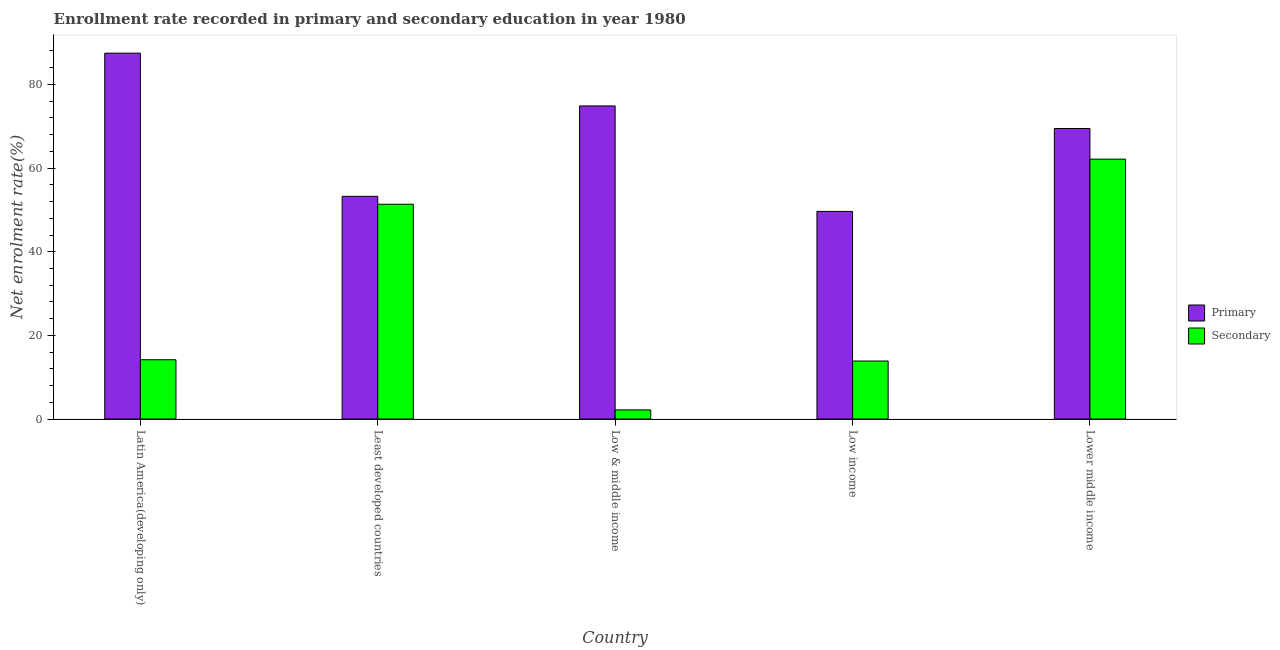How many groups of bars are there?
Provide a succinct answer. 5. How many bars are there on the 2nd tick from the right?
Your answer should be compact. 2. What is the label of the 5th group of bars from the left?
Offer a terse response. Lower middle income. What is the enrollment rate in secondary education in Latin America(developing only)?
Your answer should be compact. 14.17. Across all countries, what is the maximum enrollment rate in secondary education?
Provide a succinct answer. 62.14. Across all countries, what is the minimum enrollment rate in primary education?
Your answer should be very brief. 49.64. In which country was the enrollment rate in primary education maximum?
Your answer should be compact. Latin America(developing only). What is the total enrollment rate in secondary education in the graph?
Your answer should be very brief. 143.72. What is the difference between the enrollment rate in secondary education in Low income and that in Lower middle income?
Your answer should be compact. -48.28. What is the difference between the enrollment rate in secondary education in Lower middle income and the enrollment rate in primary education in Latin America(developing only)?
Your answer should be very brief. -25.34. What is the average enrollment rate in secondary education per country?
Make the answer very short. 28.74. What is the difference between the enrollment rate in primary education and enrollment rate in secondary education in Low & middle income?
Ensure brevity in your answer.  72.68. What is the ratio of the enrollment rate in secondary education in Latin America(developing only) to that in Low income?
Your answer should be very brief. 1.02. What is the difference between the highest and the second highest enrollment rate in secondary education?
Provide a succinct answer. 10.79. What is the difference between the highest and the lowest enrollment rate in secondary education?
Your answer should be very brief. 59.96. Is the sum of the enrollment rate in secondary education in Least developed countries and Low & middle income greater than the maximum enrollment rate in primary education across all countries?
Offer a terse response. No. What does the 1st bar from the left in Low income represents?
Ensure brevity in your answer.  Primary. What does the 1st bar from the right in Latin America(developing only) represents?
Offer a very short reply. Secondary. How many countries are there in the graph?
Offer a very short reply. 5. Does the graph contain any zero values?
Give a very brief answer. No. Does the graph contain grids?
Give a very brief answer. No. Where does the legend appear in the graph?
Provide a short and direct response. Center right. How are the legend labels stacked?
Provide a succinct answer. Vertical. What is the title of the graph?
Offer a very short reply. Enrollment rate recorded in primary and secondary education in year 1980. What is the label or title of the X-axis?
Offer a terse response. Country. What is the label or title of the Y-axis?
Keep it short and to the point. Net enrolment rate(%). What is the Net enrolment rate(%) of Primary in Latin America(developing only)?
Offer a terse response. 87.48. What is the Net enrolment rate(%) of Secondary in Latin America(developing only)?
Ensure brevity in your answer.  14.17. What is the Net enrolment rate(%) of Primary in Least developed countries?
Your answer should be compact. 53.25. What is the Net enrolment rate(%) of Secondary in Least developed countries?
Give a very brief answer. 51.36. What is the Net enrolment rate(%) of Primary in Low & middle income?
Keep it short and to the point. 74.86. What is the Net enrolment rate(%) in Secondary in Low & middle income?
Your answer should be compact. 2.18. What is the Net enrolment rate(%) in Primary in Low income?
Keep it short and to the point. 49.64. What is the Net enrolment rate(%) in Secondary in Low income?
Provide a short and direct response. 13.87. What is the Net enrolment rate(%) in Primary in Lower middle income?
Keep it short and to the point. 69.47. What is the Net enrolment rate(%) in Secondary in Lower middle income?
Make the answer very short. 62.14. Across all countries, what is the maximum Net enrolment rate(%) in Primary?
Provide a succinct answer. 87.48. Across all countries, what is the maximum Net enrolment rate(%) in Secondary?
Ensure brevity in your answer.  62.14. Across all countries, what is the minimum Net enrolment rate(%) of Primary?
Provide a succinct answer. 49.64. Across all countries, what is the minimum Net enrolment rate(%) of Secondary?
Your response must be concise. 2.18. What is the total Net enrolment rate(%) in Primary in the graph?
Your answer should be compact. 334.71. What is the total Net enrolment rate(%) in Secondary in the graph?
Keep it short and to the point. 143.72. What is the difference between the Net enrolment rate(%) of Primary in Latin America(developing only) and that in Least developed countries?
Your response must be concise. 34.23. What is the difference between the Net enrolment rate(%) of Secondary in Latin America(developing only) and that in Least developed countries?
Your answer should be compact. -37.18. What is the difference between the Net enrolment rate(%) of Primary in Latin America(developing only) and that in Low & middle income?
Make the answer very short. 12.62. What is the difference between the Net enrolment rate(%) of Secondary in Latin America(developing only) and that in Low & middle income?
Keep it short and to the point. 11.99. What is the difference between the Net enrolment rate(%) in Primary in Latin America(developing only) and that in Low income?
Offer a very short reply. 37.84. What is the difference between the Net enrolment rate(%) of Secondary in Latin America(developing only) and that in Low income?
Make the answer very short. 0.31. What is the difference between the Net enrolment rate(%) of Primary in Latin America(developing only) and that in Lower middle income?
Make the answer very short. 18.01. What is the difference between the Net enrolment rate(%) in Secondary in Latin America(developing only) and that in Lower middle income?
Keep it short and to the point. -47.97. What is the difference between the Net enrolment rate(%) of Primary in Least developed countries and that in Low & middle income?
Make the answer very short. -21.62. What is the difference between the Net enrolment rate(%) of Secondary in Least developed countries and that in Low & middle income?
Your response must be concise. 49.17. What is the difference between the Net enrolment rate(%) of Primary in Least developed countries and that in Low income?
Provide a succinct answer. 3.6. What is the difference between the Net enrolment rate(%) of Secondary in Least developed countries and that in Low income?
Provide a short and direct response. 37.49. What is the difference between the Net enrolment rate(%) in Primary in Least developed countries and that in Lower middle income?
Give a very brief answer. -16.22. What is the difference between the Net enrolment rate(%) in Secondary in Least developed countries and that in Lower middle income?
Keep it short and to the point. -10.79. What is the difference between the Net enrolment rate(%) of Primary in Low & middle income and that in Low income?
Ensure brevity in your answer.  25.22. What is the difference between the Net enrolment rate(%) in Secondary in Low & middle income and that in Low income?
Keep it short and to the point. -11.69. What is the difference between the Net enrolment rate(%) of Primary in Low & middle income and that in Lower middle income?
Provide a succinct answer. 5.39. What is the difference between the Net enrolment rate(%) in Secondary in Low & middle income and that in Lower middle income?
Offer a terse response. -59.96. What is the difference between the Net enrolment rate(%) of Primary in Low income and that in Lower middle income?
Your answer should be very brief. -19.83. What is the difference between the Net enrolment rate(%) in Secondary in Low income and that in Lower middle income?
Keep it short and to the point. -48.28. What is the difference between the Net enrolment rate(%) in Primary in Latin America(developing only) and the Net enrolment rate(%) in Secondary in Least developed countries?
Give a very brief answer. 36.13. What is the difference between the Net enrolment rate(%) of Primary in Latin America(developing only) and the Net enrolment rate(%) of Secondary in Low & middle income?
Ensure brevity in your answer.  85.3. What is the difference between the Net enrolment rate(%) in Primary in Latin America(developing only) and the Net enrolment rate(%) in Secondary in Low income?
Make the answer very short. 73.61. What is the difference between the Net enrolment rate(%) in Primary in Latin America(developing only) and the Net enrolment rate(%) in Secondary in Lower middle income?
Your answer should be compact. 25.34. What is the difference between the Net enrolment rate(%) of Primary in Least developed countries and the Net enrolment rate(%) of Secondary in Low & middle income?
Make the answer very short. 51.06. What is the difference between the Net enrolment rate(%) in Primary in Least developed countries and the Net enrolment rate(%) in Secondary in Low income?
Provide a succinct answer. 39.38. What is the difference between the Net enrolment rate(%) in Primary in Least developed countries and the Net enrolment rate(%) in Secondary in Lower middle income?
Provide a short and direct response. -8.9. What is the difference between the Net enrolment rate(%) in Primary in Low & middle income and the Net enrolment rate(%) in Secondary in Low income?
Provide a succinct answer. 61. What is the difference between the Net enrolment rate(%) of Primary in Low & middle income and the Net enrolment rate(%) of Secondary in Lower middle income?
Ensure brevity in your answer.  12.72. What is the difference between the Net enrolment rate(%) in Primary in Low income and the Net enrolment rate(%) in Secondary in Lower middle income?
Offer a very short reply. -12.5. What is the average Net enrolment rate(%) in Primary per country?
Provide a short and direct response. 66.94. What is the average Net enrolment rate(%) in Secondary per country?
Provide a succinct answer. 28.74. What is the difference between the Net enrolment rate(%) in Primary and Net enrolment rate(%) in Secondary in Latin America(developing only)?
Keep it short and to the point. 73.31. What is the difference between the Net enrolment rate(%) in Primary and Net enrolment rate(%) in Secondary in Least developed countries?
Provide a succinct answer. 1.89. What is the difference between the Net enrolment rate(%) of Primary and Net enrolment rate(%) of Secondary in Low & middle income?
Offer a terse response. 72.68. What is the difference between the Net enrolment rate(%) of Primary and Net enrolment rate(%) of Secondary in Low income?
Ensure brevity in your answer.  35.78. What is the difference between the Net enrolment rate(%) in Primary and Net enrolment rate(%) in Secondary in Lower middle income?
Your response must be concise. 7.33. What is the ratio of the Net enrolment rate(%) of Primary in Latin America(developing only) to that in Least developed countries?
Provide a succinct answer. 1.64. What is the ratio of the Net enrolment rate(%) of Secondary in Latin America(developing only) to that in Least developed countries?
Keep it short and to the point. 0.28. What is the ratio of the Net enrolment rate(%) of Primary in Latin America(developing only) to that in Low & middle income?
Ensure brevity in your answer.  1.17. What is the ratio of the Net enrolment rate(%) in Secondary in Latin America(developing only) to that in Low & middle income?
Your response must be concise. 6.5. What is the ratio of the Net enrolment rate(%) of Primary in Latin America(developing only) to that in Low income?
Keep it short and to the point. 1.76. What is the ratio of the Net enrolment rate(%) of Secondary in Latin America(developing only) to that in Low income?
Make the answer very short. 1.02. What is the ratio of the Net enrolment rate(%) in Primary in Latin America(developing only) to that in Lower middle income?
Your response must be concise. 1.26. What is the ratio of the Net enrolment rate(%) in Secondary in Latin America(developing only) to that in Lower middle income?
Give a very brief answer. 0.23. What is the ratio of the Net enrolment rate(%) in Primary in Least developed countries to that in Low & middle income?
Ensure brevity in your answer.  0.71. What is the ratio of the Net enrolment rate(%) in Secondary in Least developed countries to that in Low & middle income?
Offer a terse response. 23.54. What is the ratio of the Net enrolment rate(%) in Primary in Least developed countries to that in Low income?
Offer a very short reply. 1.07. What is the ratio of the Net enrolment rate(%) of Secondary in Least developed countries to that in Low income?
Ensure brevity in your answer.  3.7. What is the ratio of the Net enrolment rate(%) in Primary in Least developed countries to that in Lower middle income?
Keep it short and to the point. 0.77. What is the ratio of the Net enrolment rate(%) of Secondary in Least developed countries to that in Lower middle income?
Give a very brief answer. 0.83. What is the ratio of the Net enrolment rate(%) of Primary in Low & middle income to that in Low income?
Make the answer very short. 1.51. What is the ratio of the Net enrolment rate(%) of Secondary in Low & middle income to that in Low income?
Your answer should be compact. 0.16. What is the ratio of the Net enrolment rate(%) of Primary in Low & middle income to that in Lower middle income?
Your answer should be very brief. 1.08. What is the ratio of the Net enrolment rate(%) of Secondary in Low & middle income to that in Lower middle income?
Your answer should be very brief. 0.04. What is the ratio of the Net enrolment rate(%) in Primary in Low income to that in Lower middle income?
Keep it short and to the point. 0.71. What is the ratio of the Net enrolment rate(%) in Secondary in Low income to that in Lower middle income?
Make the answer very short. 0.22. What is the difference between the highest and the second highest Net enrolment rate(%) of Primary?
Offer a very short reply. 12.62. What is the difference between the highest and the second highest Net enrolment rate(%) in Secondary?
Ensure brevity in your answer.  10.79. What is the difference between the highest and the lowest Net enrolment rate(%) of Primary?
Keep it short and to the point. 37.84. What is the difference between the highest and the lowest Net enrolment rate(%) in Secondary?
Offer a very short reply. 59.96. 